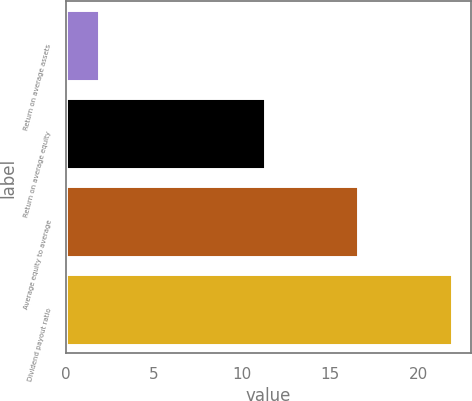Convert chart. <chart><loc_0><loc_0><loc_500><loc_500><bar_chart><fcel>Return on average assets<fcel>Return on average equity<fcel>Average equity to average<fcel>Dividend payout ratio<nl><fcel>1.9<fcel>11.3<fcel>16.6<fcel>21.9<nl></chart> 